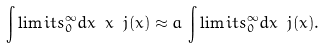Convert formula to latex. <formula><loc_0><loc_0><loc_500><loc_500>\int \lim i t s _ { 0 } ^ { \infty } d x \ x \ j ( x ) \approx a \, \int \lim i t s _ { 0 } ^ { \infty } d x \ j ( x ) .</formula> 